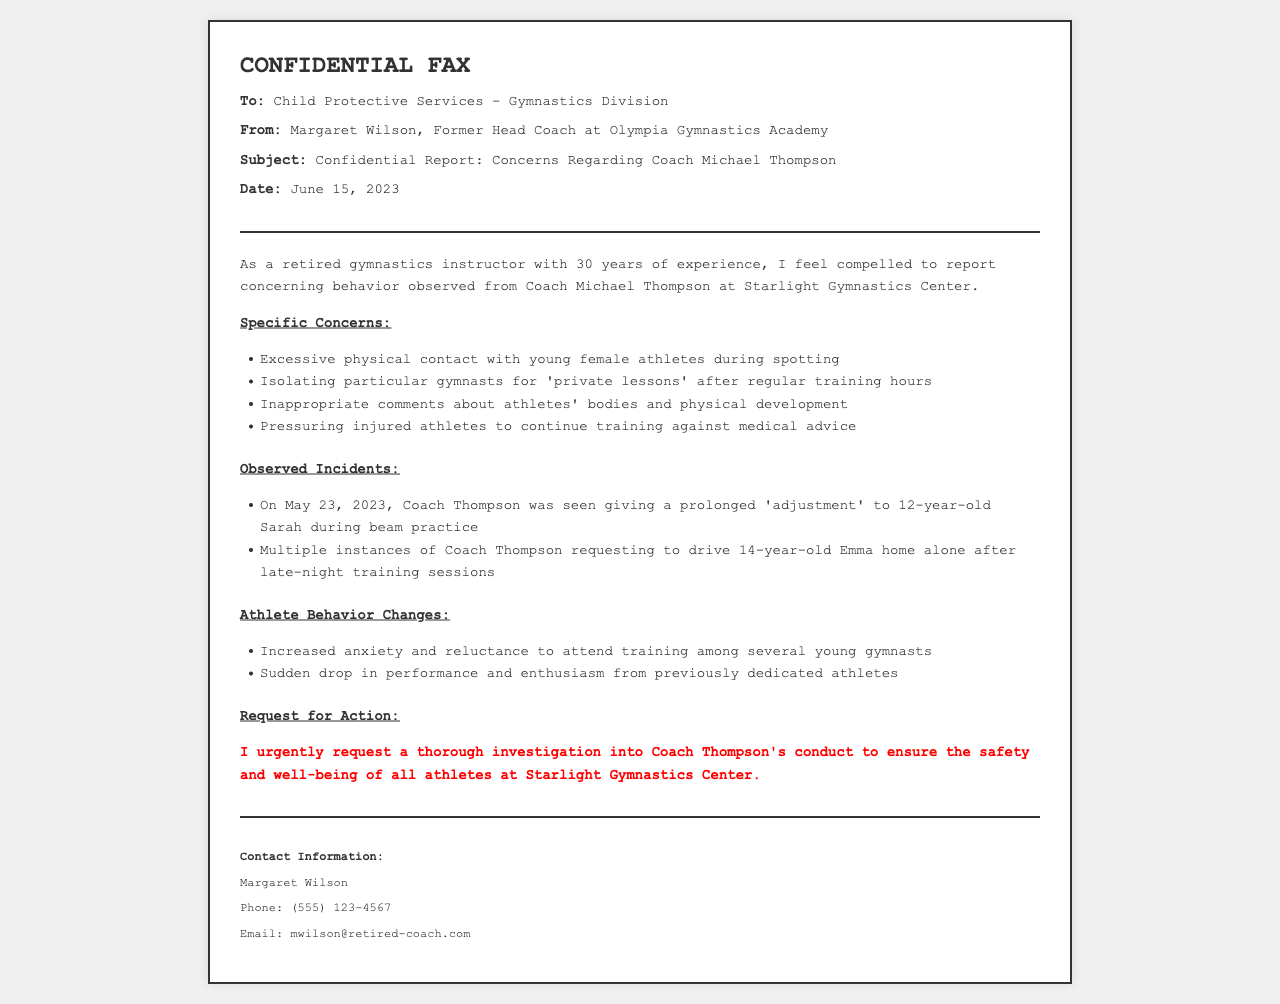What is the name of the coach involved in the report? The document refers to the coach as Coach Michael Thompson, who is the subject of the concerns reported by Margaret Wilson.
Answer: Coach Michael Thompson Who is the sender of the fax? The sender of the fax is Margaret Wilson, who is identified as the Former Head Coach at Olympia Gymnastics Academy.
Answer: Margaret Wilson What date was this fax sent? The fax provides a date of June 15, 2023, indicating when the report was submitted to Child Protective Services.
Answer: June 15, 2023 What behavior is highlighted regarding Coach Thompson's interaction with athletes? The report specifies excessive physical contact, isolating gymnasts for private lessons, inappropriate comments, and pressuring injured athletes.
Answer: Excessive physical contact Which athlete was mentioned as receiving a prolonged adjustment? The document notes that 12-year-old Sarah was the gymnast involved in the observed incident during beam practice.
Answer: Sarah What is the main request made by Margaret Wilson in the fax? The fax contains an urgent request for a thorough investigation into Coach Thompson's conduct to ensure athlete safety.
Answer: Thorough investigation What change in athlete behavior is reported? The report mentions increased anxiety and reluctance to attend training as a significant change observed among young gymnasts.
Answer: Increased anxiety How many years of experience does Margaret Wilson have as a gymnastics instructor? The document indicates that Margaret Wilson has 30 years of experience in gymnastics instruction.
Answer: 30 years What type of document is this? The document is identified as a confidential fax directed to a child protection agency regarding serious concerns.
Answer: Confidential fax 